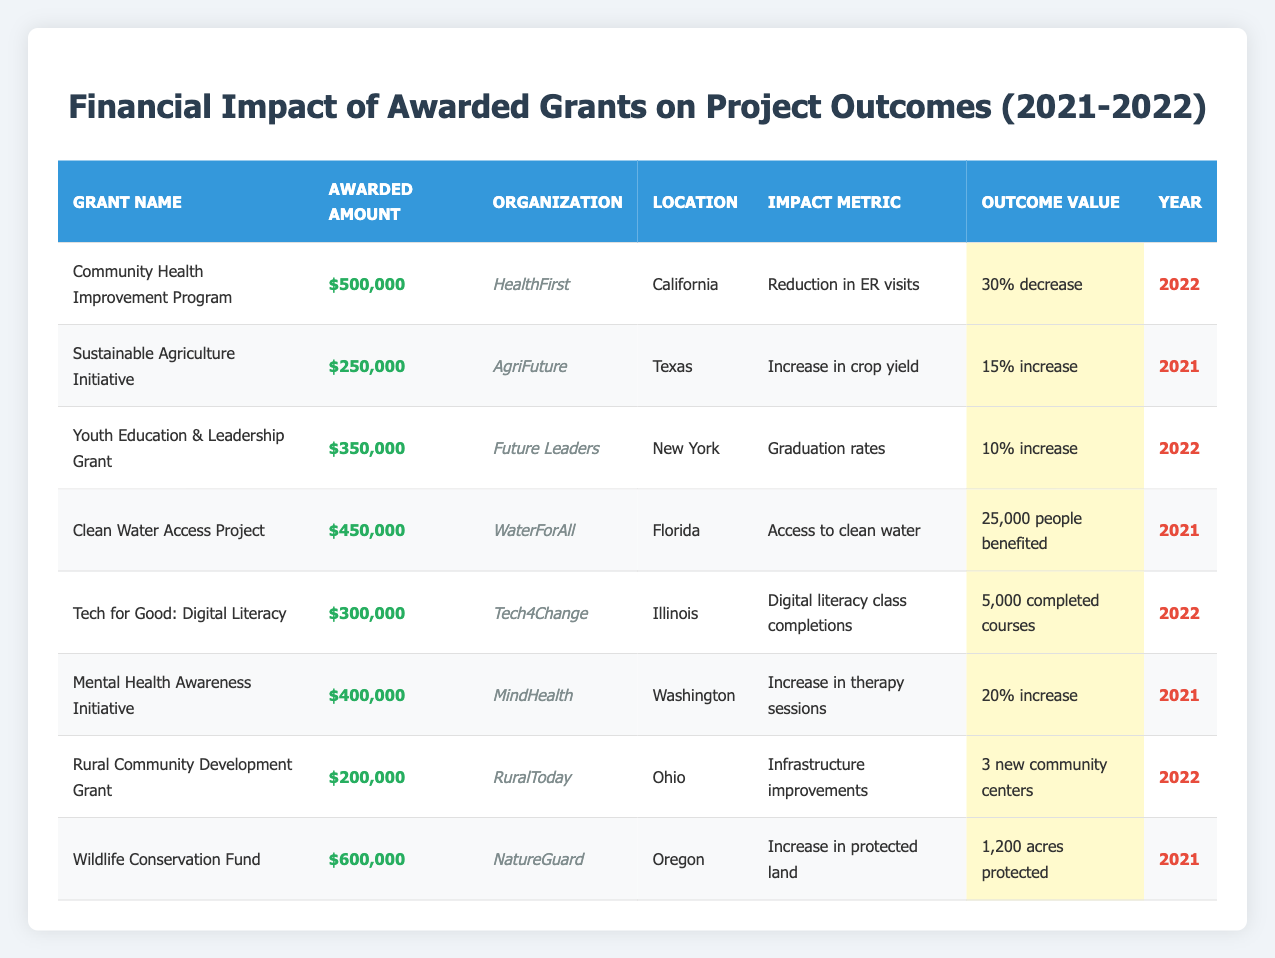What is the total awarded amount for all grants listed in the table? To find the total, I add the awarded amounts of all grants: $500,000 + $250,000 + $350,000 + $450,000 + $300,000 + $400,000 + $200,000 + $600,000 = $3,100,000.
Answer: $3,100,000 Which grant had the highest awarded amount? The highest awarded amount is $600,000 for the Wildlife Conservation Fund.
Answer: Wildlife Conservation Fund How many people benefited from the Clean Water Access Project? The Clean Water Access Project had an outcome value of 25,000 people benefited.
Answer: 25,000 What was the impact metric of the Youth Education & Leadership Grant? The impact metric for the Youth Education & Leadership Grant is graduation rates.
Answer: Graduation rates Did the Rural Community Development Grant result in any new community centers? Yes, the Rural Community Development Grant led to 3 new community centers being established.
Answer: Yes What percentage decrease in ER visits was achieved by the Community Health Improvement Program? The Community Health Improvement Program achieved a 30% decrease in ER visits.
Answer: 30% Which organization received funding for a project focused on digital literacy? The organization that received funding for a digital literacy project is Tech4Change.
Answer: Tech4Change How many grants were awarded in 2021 compared to 2022? There were 4 grants awarded in 2021 (Sustainable Agriculture Initiative, Clean Water Access Project, Mental Health Awareness Initiative, and Wildlife Conservation Fund) and 4 grants awarded in 2022 (Community Health Improvement Program, Youth Education & Leadership Grant, Tech for Good: Digital Literacy, and Rural Community Development Grant).
Answer: 4 each What was the average percentage increase for grants that specified an increase as an outcome value? The grants that specified an increase are: Sustainable Agriculture Initiative (15%), Youth Education & Leadership Grant (10%), Mental Health Awareness Initiative (20%). The average is (15 + 10 + 20) / 3 = 15%.
Answer: 15% Is there any grant focused on increasing access to clean water? Yes, the Clean Water Access Project is focused on increasing access to clean water.
Answer: Yes Which location had a project resulting in an increase in protected land? The project that resulted in an increase in protected land is in Oregon, conducted by NatureGuard.
Answer: Oregon 